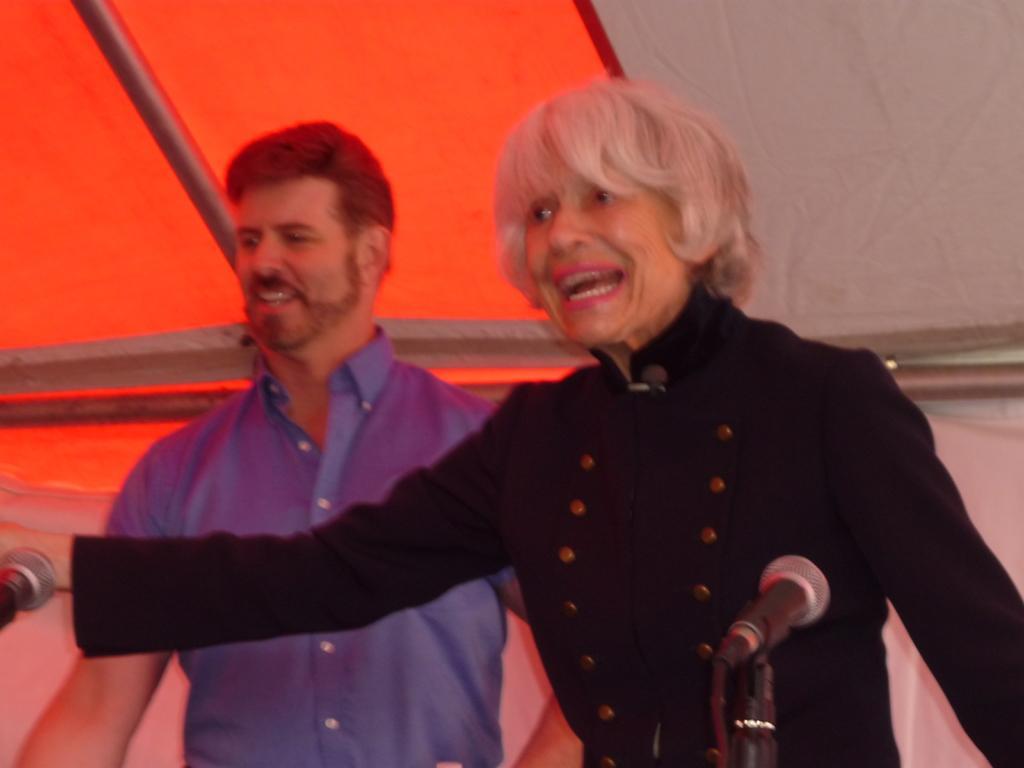Can you describe this image briefly? In front of the picture, we see the woman in the black dress is stunning. I think she is talking. In front of her, we see the microphone. Behind her, we see a man in the blue shirt is standing. He is smiling. In the background, it is in white and red color. They might be standing under the red and white tent. On the left side, we see the microphone. 